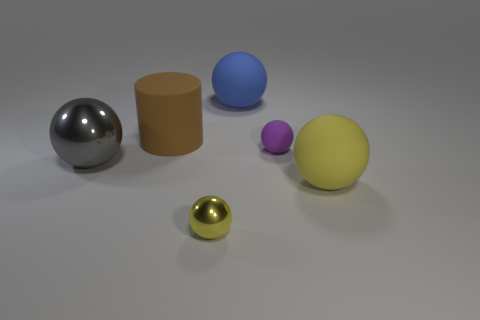Is there a shiny thing that is in front of the yellow ball that is to the right of the small rubber ball?
Give a very brief answer. Yes. What number of things are in front of the yellow rubber ball and left of the big brown thing?
Provide a succinct answer. 0. What number of big brown things are the same material as the tiny purple ball?
Your answer should be compact. 1. How big is the rubber thing left of the matte ball behind the brown rubber thing?
Your answer should be compact. Large. Is there a big shiny thing that has the same shape as the tiny rubber thing?
Offer a terse response. Yes. Does the metallic sphere behind the small yellow ball have the same size as the blue rubber object behind the purple rubber ball?
Your answer should be very brief. Yes. Is the number of yellow matte objects that are to the left of the tiny purple ball less than the number of large matte things left of the gray metal thing?
Offer a terse response. No. What material is the large object that is the same color as the small metal ball?
Ensure brevity in your answer.  Rubber. The rubber thing in front of the gray metal thing is what color?
Your response must be concise. Yellow. Does the large shiny object have the same color as the large matte cylinder?
Provide a succinct answer. No. 